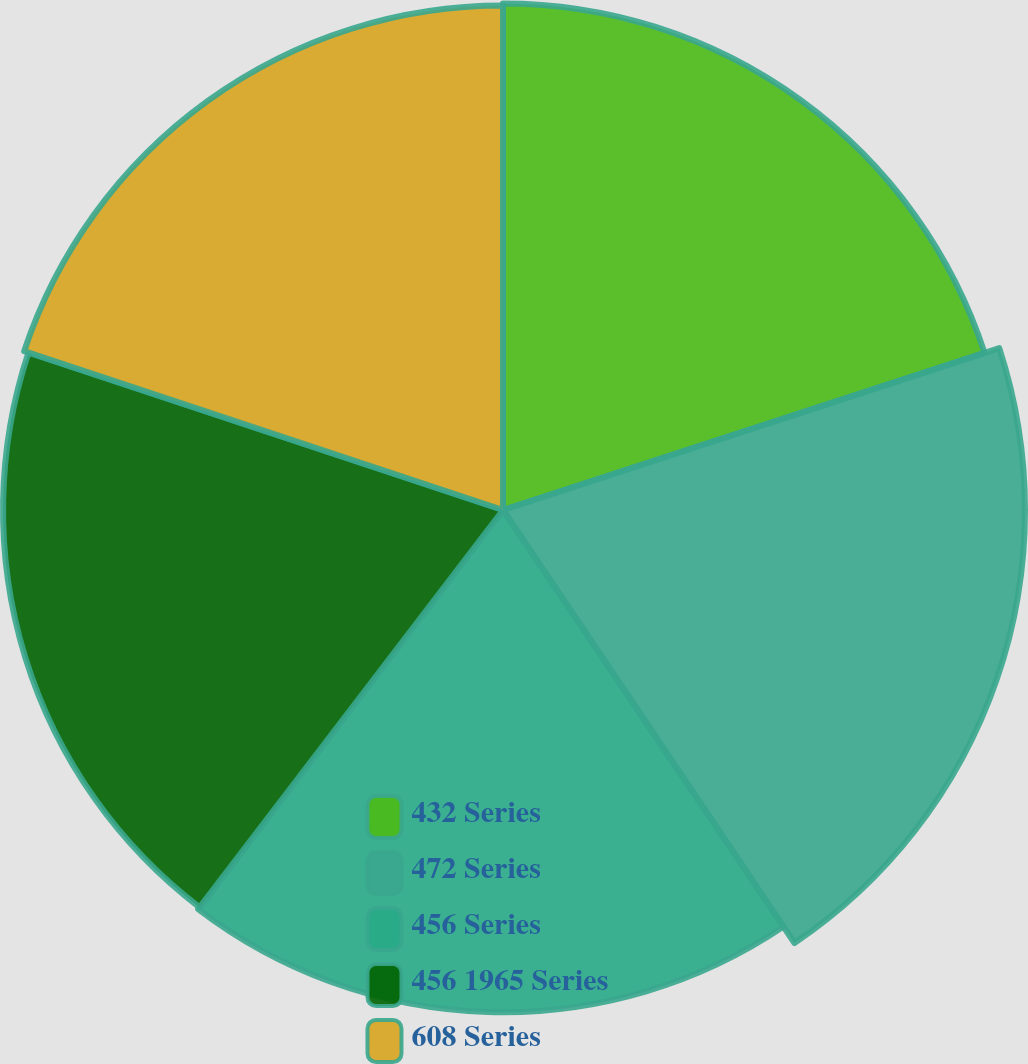Convert chart to OTSL. <chart><loc_0><loc_0><loc_500><loc_500><pie_chart><fcel>432 Series<fcel>472 Series<fcel>456 Series<fcel>456 1965 Series<fcel>608 Series<nl><fcel>19.98%<fcel>20.59%<fcel>19.81%<fcel>19.72%<fcel>19.9%<nl></chart> 